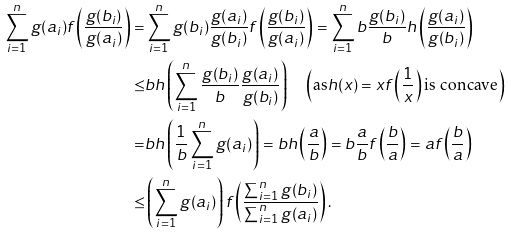Convert formula to latex. <formula><loc_0><loc_0><loc_500><loc_500>\sum _ { i = 1 } ^ { n } g ( a _ { i } ) f \left ( \frac { g ( b _ { i } ) } { g ( a _ { i } ) } \right ) = & \sum _ { i = 1 } ^ { n } g ( b _ { i } ) \frac { g ( a _ { i } ) } { g ( b _ { i } ) } f \left ( \frac { g ( b _ { i } ) } { g ( a _ { i } ) } \right ) = \sum _ { i = 1 } ^ { n } b \frac { g ( b _ { i } ) } { b } h \left ( \frac { g ( a _ { i } ) } { g ( b _ { i } ) } \right ) \\ \leq & b h \left ( \sum _ { i = 1 } ^ { n } \frac { g ( b _ { i } ) } { b } \frac { g ( a _ { i } ) } { g ( b _ { i } ) } \right ) \quad \left ( \text {as} h ( x ) = x f \left ( \frac { 1 } { x } \right ) \text {is concave} \right ) \\ = & b h \left ( \frac { 1 } { b } \sum _ { i = 1 } ^ { n } g ( a _ { i } ) \right ) = b h \left ( \frac { a } { b } \right ) = b \frac { a } { b } f \left ( \frac { b } { a } \right ) = a f \left ( \frac { b } { a } \right ) \\ \leq & \left ( \sum _ { i = 1 } ^ { n } g ( a _ { i } ) \right ) f \left ( \frac { \sum _ { i = 1 } ^ { n } g ( b _ { i } ) } { \sum _ { i = 1 } ^ { n } g ( a _ { i } ) } \right ) .</formula> 